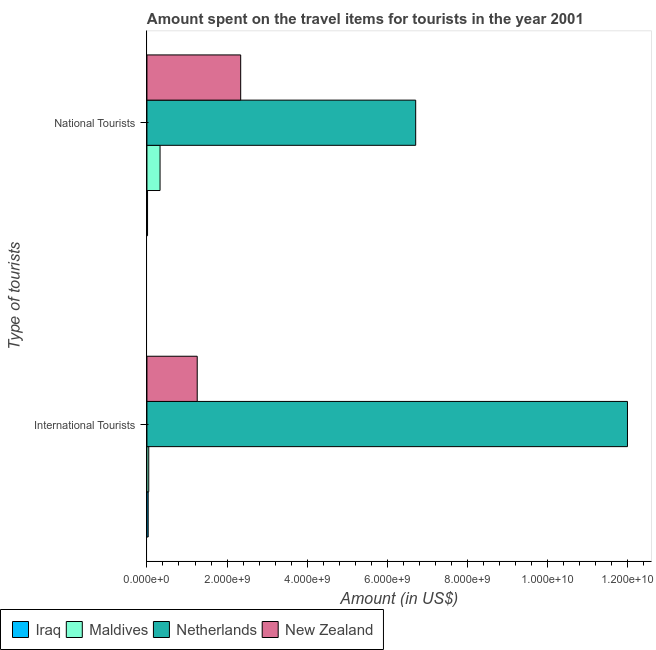How many groups of bars are there?
Ensure brevity in your answer.  2. Are the number of bars per tick equal to the number of legend labels?
Ensure brevity in your answer.  Yes. How many bars are there on the 1st tick from the bottom?
Give a very brief answer. 4. What is the label of the 1st group of bars from the top?
Offer a very short reply. National Tourists. What is the amount spent on travel items of international tourists in Maldives?
Ensure brevity in your answer.  4.50e+07. Across all countries, what is the maximum amount spent on travel items of international tourists?
Give a very brief answer. 1.20e+1. Across all countries, what is the minimum amount spent on travel items of national tourists?
Give a very brief answer. 1.50e+07. In which country was the amount spent on travel items of international tourists minimum?
Offer a very short reply. Iraq. What is the total amount spent on travel items of national tourists in the graph?
Ensure brevity in your answer.  9.39e+09. What is the difference between the amount spent on travel items of international tourists in Netherlands and that in Iraq?
Your answer should be very brief. 1.20e+1. What is the difference between the amount spent on travel items of international tourists in New Zealand and the amount spent on travel items of national tourists in Netherlands?
Give a very brief answer. -5.45e+09. What is the average amount spent on travel items of international tourists per country?
Ensure brevity in your answer.  3.33e+09. What is the difference between the amount spent on travel items of national tourists and amount spent on travel items of international tourists in New Zealand?
Provide a succinct answer. 1.08e+09. What is the ratio of the amount spent on travel items of national tourists in New Zealand to that in Maldives?
Give a very brief answer. 7.16. Is the amount spent on travel items of international tourists in Netherlands less than that in Iraq?
Provide a short and direct response. No. In how many countries, is the amount spent on travel items of national tourists greater than the average amount spent on travel items of national tourists taken over all countries?
Your answer should be very brief. 1. What does the 4th bar from the top in International Tourists represents?
Your response must be concise. Iraq. What does the 4th bar from the bottom in International Tourists represents?
Ensure brevity in your answer.  New Zealand. How many bars are there?
Provide a succinct answer. 8. How many countries are there in the graph?
Ensure brevity in your answer.  4. What is the title of the graph?
Keep it short and to the point. Amount spent on the travel items for tourists in the year 2001. Does "Mali" appear as one of the legend labels in the graph?
Provide a succinct answer. No. What is the label or title of the Y-axis?
Your answer should be compact. Type of tourists. What is the Amount (in US$) in Iraq in International Tourists?
Keep it short and to the point. 3.10e+07. What is the Amount (in US$) in Maldives in International Tourists?
Your response must be concise. 4.50e+07. What is the Amount (in US$) in Netherlands in International Tourists?
Make the answer very short. 1.20e+1. What is the Amount (in US$) of New Zealand in International Tourists?
Your answer should be very brief. 1.26e+09. What is the Amount (in US$) of Iraq in National Tourists?
Provide a short and direct response. 1.50e+07. What is the Amount (in US$) of Maldives in National Tourists?
Give a very brief answer. 3.27e+08. What is the Amount (in US$) in Netherlands in National Tourists?
Ensure brevity in your answer.  6.71e+09. What is the Amount (in US$) in New Zealand in National Tourists?
Give a very brief answer. 2.34e+09. Across all Type of tourists, what is the maximum Amount (in US$) of Iraq?
Your response must be concise. 3.10e+07. Across all Type of tourists, what is the maximum Amount (in US$) in Maldives?
Give a very brief answer. 3.27e+08. Across all Type of tourists, what is the maximum Amount (in US$) in Netherlands?
Your response must be concise. 1.20e+1. Across all Type of tourists, what is the maximum Amount (in US$) of New Zealand?
Provide a succinct answer. 2.34e+09. Across all Type of tourists, what is the minimum Amount (in US$) of Iraq?
Give a very brief answer. 1.50e+07. Across all Type of tourists, what is the minimum Amount (in US$) in Maldives?
Ensure brevity in your answer.  4.50e+07. Across all Type of tourists, what is the minimum Amount (in US$) of Netherlands?
Your answer should be compact. 6.71e+09. Across all Type of tourists, what is the minimum Amount (in US$) of New Zealand?
Make the answer very short. 1.26e+09. What is the total Amount (in US$) of Iraq in the graph?
Make the answer very short. 4.60e+07. What is the total Amount (in US$) of Maldives in the graph?
Your answer should be compact. 3.72e+08. What is the total Amount (in US$) in Netherlands in the graph?
Offer a very short reply. 1.87e+1. What is the total Amount (in US$) of New Zealand in the graph?
Your answer should be compact. 3.60e+09. What is the difference between the Amount (in US$) of Iraq in International Tourists and that in National Tourists?
Offer a very short reply. 1.60e+07. What is the difference between the Amount (in US$) in Maldives in International Tourists and that in National Tourists?
Give a very brief answer. -2.82e+08. What is the difference between the Amount (in US$) in Netherlands in International Tourists and that in National Tourists?
Keep it short and to the point. 5.29e+09. What is the difference between the Amount (in US$) in New Zealand in International Tourists and that in National Tourists?
Make the answer very short. -1.08e+09. What is the difference between the Amount (in US$) of Iraq in International Tourists and the Amount (in US$) of Maldives in National Tourists?
Your response must be concise. -2.96e+08. What is the difference between the Amount (in US$) of Iraq in International Tourists and the Amount (in US$) of Netherlands in National Tourists?
Your answer should be compact. -6.68e+09. What is the difference between the Amount (in US$) of Iraq in International Tourists and the Amount (in US$) of New Zealand in National Tourists?
Your response must be concise. -2.31e+09. What is the difference between the Amount (in US$) in Maldives in International Tourists and the Amount (in US$) in Netherlands in National Tourists?
Your response must be concise. -6.66e+09. What is the difference between the Amount (in US$) in Maldives in International Tourists and the Amount (in US$) in New Zealand in National Tourists?
Offer a very short reply. -2.30e+09. What is the difference between the Amount (in US$) of Netherlands in International Tourists and the Amount (in US$) of New Zealand in National Tourists?
Your response must be concise. 9.65e+09. What is the average Amount (in US$) in Iraq per Type of tourists?
Provide a succinct answer. 2.30e+07. What is the average Amount (in US$) in Maldives per Type of tourists?
Your answer should be very brief. 1.86e+08. What is the average Amount (in US$) in Netherlands per Type of tourists?
Ensure brevity in your answer.  9.35e+09. What is the average Amount (in US$) of New Zealand per Type of tourists?
Provide a short and direct response. 1.80e+09. What is the difference between the Amount (in US$) of Iraq and Amount (in US$) of Maldives in International Tourists?
Your answer should be very brief. -1.40e+07. What is the difference between the Amount (in US$) in Iraq and Amount (in US$) in Netherlands in International Tourists?
Your response must be concise. -1.20e+1. What is the difference between the Amount (in US$) in Iraq and Amount (in US$) in New Zealand in International Tourists?
Provide a short and direct response. -1.22e+09. What is the difference between the Amount (in US$) of Maldives and Amount (in US$) of Netherlands in International Tourists?
Offer a very short reply. -1.19e+1. What is the difference between the Amount (in US$) of Maldives and Amount (in US$) of New Zealand in International Tourists?
Provide a short and direct response. -1.21e+09. What is the difference between the Amount (in US$) of Netherlands and Amount (in US$) of New Zealand in International Tourists?
Keep it short and to the point. 1.07e+1. What is the difference between the Amount (in US$) of Iraq and Amount (in US$) of Maldives in National Tourists?
Ensure brevity in your answer.  -3.12e+08. What is the difference between the Amount (in US$) in Iraq and Amount (in US$) in Netherlands in National Tourists?
Provide a short and direct response. -6.69e+09. What is the difference between the Amount (in US$) of Iraq and Amount (in US$) of New Zealand in National Tourists?
Your answer should be compact. -2.32e+09. What is the difference between the Amount (in US$) of Maldives and Amount (in US$) of Netherlands in National Tourists?
Offer a terse response. -6.38e+09. What is the difference between the Amount (in US$) of Maldives and Amount (in US$) of New Zealand in National Tourists?
Your answer should be compact. -2.01e+09. What is the difference between the Amount (in US$) of Netherlands and Amount (in US$) of New Zealand in National Tourists?
Provide a succinct answer. 4.37e+09. What is the ratio of the Amount (in US$) in Iraq in International Tourists to that in National Tourists?
Offer a very short reply. 2.07. What is the ratio of the Amount (in US$) of Maldives in International Tourists to that in National Tourists?
Offer a terse response. 0.14. What is the ratio of the Amount (in US$) of Netherlands in International Tourists to that in National Tourists?
Your response must be concise. 1.79. What is the ratio of the Amount (in US$) of New Zealand in International Tourists to that in National Tourists?
Give a very brief answer. 0.54. What is the difference between the highest and the second highest Amount (in US$) in Iraq?
Your response must be concise. 1.60e+07. What is the difference between the highest and the second highest Amount (in US$) in Maldives?
Make the answer very short. 2.82e+08. What is the difference between the highest and the second highest Amount (in US$) in Netherlands?
Keep it short and to the point. 5.29e+09. What is the difference between the highest and the second highest Amount (in US$) in New Zealand?
Give a very brief answer. 1.08e+09. What is the difference between the highest and the lowest Amount (in US$) of Iraq?
Provide a succinct answer. 1.60e+07. What is the difference between the highest and the lowest Amount (in US$) of Maldives?
Offer a very short reply. 2.82e+08. What is the difference between the highest and the lowest Amount (in US$) in Netherlands?
Offer a terse response. 5.29e+09. What is the difference between the highest and the lowest Amount (in US$) of New Zealand?
Offer a very short reply. 1.08e+09. 